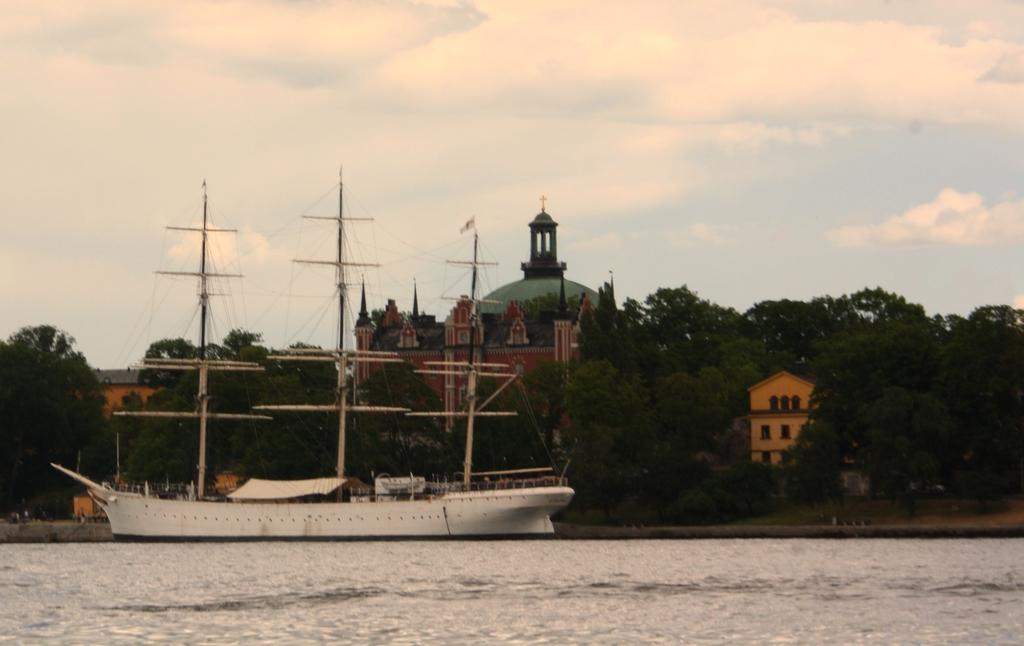What is the main subject of the image? The main subject of the image is a ship. Where is the ship located? The ship is on a river. What can be seen in the background of the image? There are trees, buildings, and the sky visible in the background of the image. Can you see any fairies flying around the ship in the image? There are no fairies present in the image. What type of roof is visible on the buildings in the background? The image does not provide enough detail to determine the type of roof on the buildings in the background. 